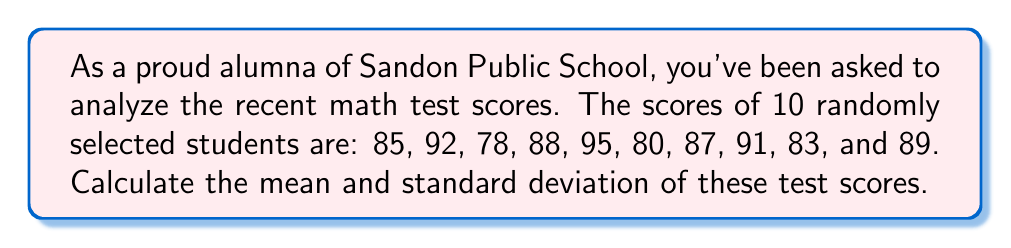Provide a solution to this math problem. Let's approach this step-by-step:

1. Calculate the mean:
   The mean is the sum of all scores divided by the number of scores.
   
   $$ \text{Mean} = \frac{\sum x_i}{n} $$
   
   $$ \text{Mean} = \frac{85 + 92 + 78 + 88 + 95 + 80 + 87 + 91 + 83 + 89}{10} = \frac{868}{10} = 86.8 $$

2. Calculate the standard deviation:
   The standard deviation is the square root of the variance, which is the average of the squared differences from the mean.

   a. Calculate the differences from the mean and square them:
      $$(85 - 86.8)^2 = (-1.8)^2 = 3.24$$
      $$(92 - 86.8)^2 = (5.2)^2 = 27.04$$
      $$(78 - 86.8)^2 = (-8.8)^2 = 77.44$$
      $$(88 - 86.8)^2 = (1.2)^2 = 1.44$$
      $$(95 - 86.8)^2 = (8.2)^2 = 67.24$$
      $$(80 - 86.8)^2 = (-6.8)^2 = 46.24$$
      $$(87 - 86.8)^2 = (0.2)^2 = 0.04$$
      $$(91 - 86.8)^2 = (4.2)^2 = 17.64$$
      $$(83 - 86.8)^2 = (-3.8)^2 = 14.44$$
      $$(89 - 86.8)^2 = (2.2)^2 = 4.84$$

   b. Sum these squared differences:
      $$3.24 + 27.04 + 77.44 + 1.44 + 67.24 + 46.24 + 0.04 + 17.64 + 14.44 + 4.84 = 259.6$$

   c. Divide by (n-1) to get the variance:
      $$ \text{Variance} = \frac{259.6}{9} = 28.84444... $$

   d. Take the square root to get the standard deviation:
      $$ \text{Standard Deviation} = \sqrt{28.84444...} = 5.37 \text{ (rounded to 2 decimal places)} $$
Answer: Mean: 86.8, Standard Deviation: 5.37 